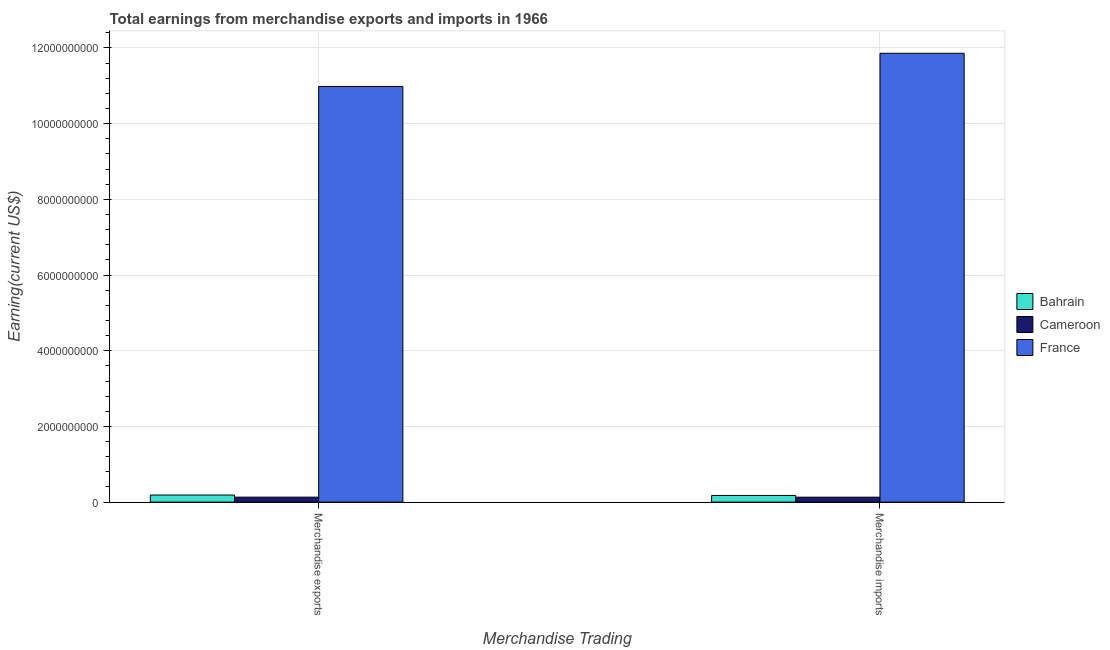How many different coloured bars are there?
Give a very brief answer. 3. How many groups of bars are there?
Make the answer very short. 2. Are the number of bars per tick equal to the number of legend labels?
Make the answer very short. Yes. Are the number of bars on each tick of the X-axis equal?
Provide a succinct answer. Yes. How many bars are there on the 1st tick from the left?
Provide a succinct answer. 3. How many bars are there on the 1st tick from the right?
Make the answer very short. 3. What is the earnings from merchandise exports in Cameroon?
Give a very brief answer. 1.31e+08. Across all countries, what is the maximum earnings from merchandise imports?
Give a very brief answer. 1.19e+1. Across all countries, what is the minimum earnings from merchandise exports?
Your response must be concise. 1.31e+08. In which country was the earnings from merchandise exports maximum?
Make the answer very short. France. In which country was the earnings from merchandise exports minimum?
Your answer should be compact. Cameroon. What is the total earnings from merchandise exports in the graph?
Provide a succinct answer. 1.13e+1. What is the difference between the earnings from merchandise exports in Bahrain and that in France?
Your answer should be compact. -1.08e+1. What is the difference between the earnings from merchandise exports in Cameroon and the earnings from merchandise imports in France?
Your response must be concise. -1.17e+1. What is the average earnings from merchandise imports per country?
Offer a terse response. 4.06e+09. What is the difference between the earnings from merchandise exports and earnings from merchandise imports in Cameroon?
Offer a terse response. 5.79e+05. In how many countries, is the earnings from merchandise exports greater than 7200000000 US$?
Your answer should be compact. 1. What is the ratio of the earnings from merchandise exports in Cameroon to that in Bahrain?
Keep it short and to the point. 0.7. Is the earnings from merchandise exports in France less than that in Cameroon?
Give a very brief answer. No. What does the 1st bar from the left in Merchandise imports represents?
Make the answer very short. Bahrain. What does the 2nd bar from the right in Merchandise imports represents?
Your answer should be compact. Cameroon. How many countries are there in the graph?
Provide a succinct answer. 3. Are the values on the major ticks of Y-axis written in scientific E-notation?
Your answer should be compact. No. How many legend labels are there?
Make the answer very short. 3. How are the legend labels stacked?
Ensure brevity in your answer.  Vertical. What is the title of the graph?
Your response must be concise. Total earnings from merchandise exports and imports in 1966. Does "Guyana" appear as one of the legend labels in the graph?
Give a very brief answer. No. What is the label or title of the X-axis?
Your answer should be very brief. Merchandise Trading. What is the label or title of the Y-axis?
Provide a succinct answer. Earning(current US$). What is the Earning(current US$) in Bahrain in Merchandise exports?
Provide a short and direct response. 1.87e+08. What is the Earning(current US$) of Cameroon in Merchandise exports?
Keep it short and to the point. 1.31e+08. What is the Earning(current US$) of France in Merchandise exports?
Provide a succinct answer. 1.10e+1. What is the Earning(current US$) in Bahrain in Merchandise imports?
Your response must be concise. 1.76e+08. What is the Earning(current US$) in Cameroon in Merchandise imports?
Your answer should be compact. 1.31e+08. What is the Earning(current US$) in France in Merchandise imports?
Ensure brevity in your answer.  1.19e+1. Across all Merchandise Trading, what is the maximum Earning(current US$) of Bahrain?
Offer a terse response. 1.87e+08. Across all Merchandise Trading, what is the maximum Earning(current US$) in Cameroon?
Your answer should be compact. 1.31e+08. Across all Merchandise Trading, what is the maximum Earning(current US$) in France?
Your answer should be compact. 1.19e+1. Across all Merchandise Trading, what is the minimum Earning(current US$) in Bahrain?
Your answer should be very brief. 1.76e+08. Across all Merchandise Trading, what is the minimum Earning(current US$) of Cameroon?
Provide a short and direct response. 1.31e+08. Across all Merchandise Trading, what is the minimum Earning(current US$) in France?
Your answer should be very brief. 1.10e+1. What is the total Earning(current US$) of Bahrain in the graph?
Make the answer very short. 3.63e+08. What is the total Earning(current US$) of Cameroon in the graph?
Give a very brief answer. 2.62e+08. What is the total Earning(current US$) in France in the graph?
Provide a succinct answer. 2.28e+1. What is the difference between the Earning(current US$) in Bahrain in Merchandise exports and that in Merchandise imports?
Keep it short and to the point. 1.13e+07. What is the difference between the Earning(current US$) of Cameroon in Merchandise exports and that in Merchandise imports?
Make the answer very short. 5.79e+05. What is the difference between the Earning(current US$) of France in Merchandise exports and that in Merchandise imports?
Your response must be concise. -8.77e+08. What is the difference between the Earning(current US$) of Bahrain in Merchandise exports and the Earning(current US$) of Cameroon in Merchandise imports?
Provide a short and direct response. 5.66e+07. What is the difference between the Earning(current US$) of Bahrain in Merchandise exports and the Earning(current US$) of France in Merchandise imports?
Give a very brief answer. -1.17e+1. What is the difference between the Earning(current US$) in Cameroon in Merchandise exports and the Earning(current US$) in France in Merchandise imports?
Give a very brief answer. -1.17e+1. What is the average Earning(current US$) of Bahrain per Merchandise Trading?
Offer a terse response. 1.82e+08. What is the average Earning(current US$) of Cameroon per Merchandise Trading?
Provide a succinct answer. 1.31e+08. What is the average Earning(current US$) of France per Merchandise Trading?
Give a very brief answer. 1.14e+1. What is the difference between the Earning(current US$) in Bahrain and Earning(current US$) in Cameroon in Merchandise exports?
Make the answer very short. 5.60e+07. What is the difference between the Earning(current US$) in Bahrain and Earning(current US$) in France in Merchandise exports?
Offer a very short reply. -1.08e+1. What is the difference between the Earning(current US$) of Cameroon and Earning(current US$) of France in Merchandise exports?
Make the answer very short. -1.09e+1. What is the difference between the Earning(current US$) in Bahrain and Earning(current US$) in Cameroon in Merchandise imports?
Your answer should be very brief. 4.53e+07. What is the difference between the Earning(current US$) in Bahrain and Earning(current US$) in France in Merchandise imports?
Provide a succinct answer. -1.17e+1. What is the difference between the Earning(current US$) in Cameroon and Earning(current US$) in France in Merchandise imports?
Your answer should be compact. -1.17e+1. What is the ratio of the Earning(current US$) of Bahrain in Merchandise exports to that in Merchandise imports?
Keep it short and to the point. 1.06. What is the ratio of the Earning(current US$) in France in Merchandise exports to that in Merchandise imports?
Make the answer very short. 0.93. What is the difference between the highest and the second highest Earning(current US$) in Bahrain?
Provide a short and direct response. 1.13e+07. What is the difference between the highest and the second highest Earning(current US$) in Cameroon?
Offer a terse response. 5.79e+05. What is the difference between the highest and the second highest Earning(current US$) of France?
Give a very brief answer. 8.77e+08. What is the difference between the highest and the lowest Earning(current US$) in Bahrain?
Provide a short and direct response. 1.13e+07. What is the difference between the highest and the lowest Earning(current US$) in Cameroon?
Ensure brevity in your answer.  5.79e+05. What is the difference between the highest and the lowest Earning(current US$) of France?
Offer a very short reply. 8.77e+08. 